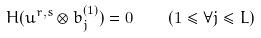Convert formula to latex. <formula><loc_0><loc_0><loc_500><loc_500>H ( u ^ { r , s } \otimes b _ { j } ^ { ( 1 ) } ) = 0 \quad ( 1 \leq \forall j \leq L )</formula> 